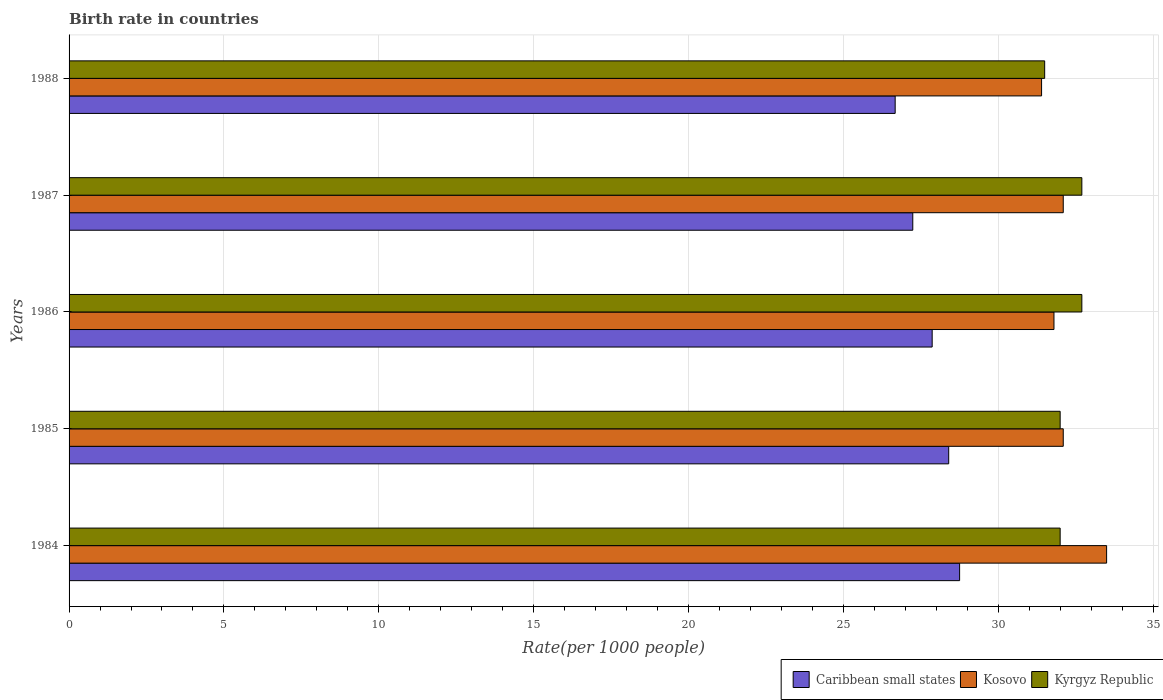How many different coloured bars are there?
Offer a terse response. 3. Are the number of bars on each tick of the Y-axis equal?
Offer a very short reply. Yes. In how many cases, is the number of bars for a given year not equal to the number of legend labels?
Your answer should be compact. 0. What is the birth rate in Kosovo in 1987?
Make the answer very short. 32.1. Across all years, what is the maximum birth rate in Kosovo?
Your answer should be very brief. 33.5. Across all years, what is the minimum birth rate in Caribbean small states?
Make the answer very short. 26.67. What is the total birth rate in Kosovo in the graph?
Give a very brief answer. 160.9. What is the difference between the birth rate in Kyrgyz Republic in 1984 and that in 1987?
Give a very brief answer. -0.7. What is the difference between the birth rate in Kyrgyz Republic in 1987 and the birth rate in Caribbean small states in 1985?
Keep it short and to the point. 4.3. What is the average birth rate in Kosovo per year?
Your answer should be very brief. 32.18. In the year 1986, what is the difference between the birth rate in Kyrgyz Republic and birth rate in Kosovo?
Your answer should be compact. 0.9. In how many years, is the birth rate in Caribbean small states greater than 26 ?
Your answer should be very brief. 5. What is the ratio of the birth rate in Caribbean small states in 1987 to that in 1988?
Your answer should be very brief. 1.02. Is the birth rate in Kosovo in 1985 less than that in 1988?
Your answer should be compact. No. Is the difference between the birth rate in Kyrgyz Republic in 1987 and 1988 greater than the difference between the birth rate in Kosovo in 1987 and 1988?
Offer a very short reply. Yes. What is the difference between the highest and the second highest birth rate in Caribbean small states?
Make the answer very short. 0.35. What is the difference between the highest and the lowest birth rate in Kosovo?
Provide a short and direct response. 2.1. In how many years, is the birth rate in Kyrgyz Republic greater than the average birth rate in Kyrgyz Republic taken over all years?
Your response must be concise. 2. Is the sum of the birth rate in Kyrgyz Republic in 1984 and 1988 greater than the maximum birth rate in Kosovo across all years?
Make the answer very short. Yes. What does the 2nd bar from the top in 1987 represents?
Your answer should be very brief. Kosovo. What does the 1st bar from the bottom in 1985 represents?
Your answer should be very brief. Caribbean small states. Is it the case that in every year, the sum of the birth rate in Caribbean small states and birth rate in Kosovo is greater than the birth rate in Kyrgyz Republic?
Provide a succinct answer. Yes. How many bars are there?
Your answer should be compact. 15. Are all the bars in the graph horizontal?
Offer a terse response. Yes. How many years are there in the graph?
Give a very brief answer. 5. Are the values on the major ticks of X-axis written in scientific E-notation?
Offer a very short reply. No. Where does the legend appear in the graph?
Make the answer very short. Bottom right. What is the title of the graph?
Make the answer very short. Birth rate in countries. What is the label or title of the X-axis?
Make the answer very short. Rate(per 1000 people). What is the label or title of the Y-axis?
Offer a terse response. Years. What is the Rate(per 1000 people) of Caribbean small states in 1984?
Provide a short and direct response. 28.75. What is the Rate(per 1000 people) in Kosovo in 1984?
Keep it short and to the point. 33.5. What is the Rate(per 1000 people) in Caribbean small states in 1985?
Provide a short and direct response. 28.4. What is the Rate(per 1000 people) of Kosovo in 1985?
Make the answer very short. 32.1. What is the Rate(per 1000 people) in Caribbean small states in 1986?
Offer a very short reply. 27.87. What is the Rate(per 1000 people) in Kosovo in 1986?
Offer a terse response. 31.8. What is the Rate(per 1000 people) of Kyrgyz Republic in 1986?
Offer a very short reply. 32.7. What is the Rate(per 1000 people) in Caribbean small states in 1987?
Your answer should be compact. 27.24. What is the Rate(per 1000 people) in Kosovo in 1987?
Offer a terse response. 32.1. What is the Rate(per 1000 people) in Kyrgyz Republic in 1987?
Give a very brief answer. 32.7. What is the Rate(per 1000 people) of Caribbean small states in 1988?
Your answer should be compact. 26.67. What is the Rate(per 1000 people) of Kosovo in 1988?
Your response must be concise. 31.4. What is the Rate(per 1000 people) of Kyrgyz Republic in 1988?
Your answer should be compact. 31.5. Across all years, what is the maximum Rate(per 1000 people) of Caribbean small states?
Give a very brief answer. 28.75. Across all years, what is the maximum Rate(per 1000 people) of Kosovo?
Your answer should be very brief. 33.5. Across all years, what is the maximum Rate(per 1000 people) of Kyrgyz Republic?
Your answer should be very brief. 32.7. Across all years, what is the minimum Rate(per 1000 people) of Caribbean small states?
Provide a short and direct response. 26.67. Across all years, what is the minimum Rate(per 1000 people) of Kosovo?
Offer a terse response. 31.4. Across all years, what is the minimum Rate(per 1000 people) of Kyrgyz Republic?
Offer a terse response. 31.5. What is the total Rate(per 1000 people) of Caribbean small states in the graph?
Provide a succinct answer. 138.94. What is the total Rate(per 1000 people) of Kosovo in the graph?
Offer a terse response. 160.9. What is the total Rate(per 1000 people) of Kyrgyz Republic in the graph?
Give a very brief answer. 160.9. What is the difference between the Rate(per 1000 people) of Caribbean small states in 1984 and that in 1985?
Offer a terse response. 0.35. What is the difference between the Rate(per 1000 people) of Caribbean small states in 1984 and that in 1986?
Your answer should be compact. 0.89. What is the difference between the Rate(per 1000 people) of Kyrgyz Republic in 1984 and that in 1986?
Keep it short and to the point. -0.7. What is the difference between the Rate(per 1000 people) of Caribbean small states in 1984 and that in 1987?
Your answer should be compact. 1.51. What is the difference between the Rate(per 1000 people) in Kosovo in 1984 and that in 1987?
Your answer should be compact. 1.4. What is the difference between the Rate(per 1000 people) of Kyrgyz Republic in 1984 and that in 1987?
Make the answer very short. -0.7. What is the difference between the Rate(per 1000 people) of Caribbean small states in 1984 and that in 1988?
Give a very brief answer. 2.08. What is the difference between the Rate(per 1000 people) of Kosovo in 1984 and that in 1988?
Keep it short and to the point. 2.1. What is the difference between the Rate(per 1000 people) of Kyrgyz Republic in 1984 and that in 1988?
Offer a terse response. 0.5. What is the difference between the Rate(per 1000 people) of Caribbean small states in 1985 and that in 1986?
Ensure brevity in your answer.  0.53. What is the difference between the Rate(per 1000 people) in Kyrgyz Republic in 1985 and that in 1986?
Provide a short and direct response. -0.7. What is the difference between the Rate(per 1000 people) of Caribbean small states in 1985 and that in 1987?
Make the answer very short. 1.16. What is the difference between the Rate(per 1000 people) in Caribbean small states in 1985 and that in 1988?
Your response must be concise. 1.73. What is the difference between the Rate(per 1000 people) of Kosovo in 1985 and that in 1988?
Ensure brevity in your answer.  0.7. What is the difference between the Rate(per 1000 people) in Caribbean small states in 1986 and that in 1987?
Give a very brief answer. 0.63. What is the difference between the Rate(per 1000 people) in Kyrgyz Republic in 1986 and that in 1987?
Offer a terse response. 0. What is the difference between the Rate(per 1000 people) of Caribbean small states in 1986 and that in 1988?
Give a very brief answer. 1.19. What is the difference between the Rate(per 1000 people) in Kosovo in 1986 and that in 1988?
Your answer should be very brief. 0.4. What is the difference between the Rate(per 1000 people) of Caribbean small states in 1987 and that in 1988?
Offer a terse response. 0.57. What is the difference between the Rate(per 1000 people) in Kosovo in 1987 and that in 1988?
Your answer should be compact. 0.7. What is the difference between the Rate(per 1000 people) of Kyrgyz Republic in 1987 and that in 1988?
Your answer should be compact. 1.2. What is the difference between the Rate(per 1000 people) in Caribbean small states in 1984 and the Rate(per 1000 people) in Kosovo in 1985?
Keep it short and to the point. -3.35. What is the difference between the Rate(per 1000 people) in Caribbean small states in 1984 and the Rate(per 1000 people) in Kyrgyz Republic in 1985?
Ensure brevity in your answer.  -3.25. What is the difference between the Rate(per 1000 people) in Caribbean small states in 1984 and the Rate(per 1000 people) in Kosovo in 1986?
Keep it short and to the point. -3.05. What is the difference between the Rate(per 1000 people) of Caribbean small states in 1984 and the Rate(per 1000 people) of Kyrgyz Republic in 1986?
Your answer should be compact. -3.95. What is the difference between the Rate(per 1000 people) in Caribbean small states in 1984 and the Rate(per 1000 people) in Kosovo in 1987?
Offer a terse response. -3.35. What is the difference between the Rate(per 1000 people) in Caribbean small states in 1984 and the Rate(per 1000 people) in Kyrgyz Republic in 1987?
Your response must be concise. -3.95. What is the difference between the Rate(per 1000 people) of Caribbean small states in 1984 and the Rate(per 1000 people) of Kosovo in 1988?
Your answer should be compact. -2.65. What is the difference between the Rate(per 1000 people) in Caribbean small states in 1984 and the Rate(per 1000 people) in Kyrgyz Republic in 1988?
Give a very brief answer. -2.75. What is the difference between the Rate(per 1000 people) in Caribbean small states in 1985 and the Rate(per 1000 people) in Kosovo in 1986?
Offer a terse response. -3.4. What is the difference between the Rate(per 1000 people) of Caribbean small states in 1985 and the Rate(per 1000 people) of Kyrgyz Republic in 1986?
Keep it short and to the point. -4.3. What is the difference between the Rate(per 1000 people) of Caribbean small states in 1985 and the Rate(per 1000 people) of Kosovo in 1987?
Your answer should be very brief. -3.7. What is the difference between the Rate(per 1000 people) of Caribbean small states in 1985 and the Rate(per 1000 people) of Kyrgyz Republic in 1987?
Your response must be concise. -4.3. What is the difference between the Rate(per 1000 people) in Kosovo in 1985 and the Rate(per 1000 people) in Kyrgyz Republic in 1987?
Give a very brief answer. -0.6. What is the difference between the Rate(per 1000 people) in Caribbean small states in 1985 and the Rate(per 1000 people) in Kosovo in 1988?
Provide a succinct answer. -3. What is the difference between the Rate(per 1000 people) in Caribbean small states in 1985 and the Rate(per 1000 people) in Kyrgyz Republic in 1988?
Give a very brief answer. -3.1. What is the difference between the Rate(per 1000 people) in Caribbean small states in 1986 and the Rate(per 1000 people) in Kosovo in 1987?
Your response must be concise. -4.23. What is the difference between the Rate(per 1000 people) of Caribbean small states in 1986 and the Rate(per 1000 people) of Kyrgyz Republic in 1987?
Offer a terse response. -4.83. What is the difference between the Rate(per 1000 people) in Kosovo in 1986 and the Rate(per 1000 people) in Kyrgyz Republic in 1987?
Your answer should be very brief. -0.9. What is the difference between the Rate(per 1000 people) in Caribbean small states in 1986 and the Rate(per 1000 people) in Kosovo in 1988?
Provide a short and direct response. -3.53. What is the difference between the Rate(per 1000 people) in Caribbean small states in 1986 and the Rate(per 1000 people) in Kyrgyz Republic in 1988?
Offer a very short reply. -3.63. What is the difference between the Rate(per 1000 people) in Kosovo in 1986 and the Rate(per 1000 people) in Kyrgyz Republic in 1988?
Offer a very short reply. 0.3. What is the difference between the Rate(per 1000 people) of Caribbean small states in 1987 and the Rate(per 1000 people) of Kosovo in 1988?
Make the answer very short. -4.16. What is the difference between the Rate(per 1000 people) of Caribbean small states in 1987 and the Rate(per 1000 people) of Kyrgyz Republic in 1988?
Make the answer very short. -4.26. What is the average Rate(per 1000 people) of Caribbean small states per year?
Keep it short and to the point. 27.79. What is the average Rate(per 1000 people) of Kosovo per year?
Your answer should be very brief. 32.18. What is the average Rate(per 1000 people) of Kyrgyz Republic per year?
Offer a terse response. 32.18. In the year 1984, what is the difference between the Rate(per 1000 people) of Caribbean small states and Rate(per 1000 people) of Kosovo?
Offer a very short reply. -4.75. In the year 1984, what is the difference between the Rate(per 1000 people) in Caribbean small states and Rate(per 1000 people) in Kyrgyz Republic?
Keep it short and to the point. -3.25. In the year 1985, what is the difference between the Rate(per 1000 people) of Caribbean small states and Rate(per 1000 people) of Kosovo?
Offer a very short reply. -3.7. In the year 1985, what is the difference between the Rate(per 1000 people) of Caribbean small states and Rate(per 1000 people) of Kyrgyz Republic?
Your answer should be compact. -3.6. In the year 1985, what is the difference between the Rate(per 1000 people) in Kosovo and Rate(per 1000 people) in Kyrgyz Republic?
Offer a very short reply. 0.1. In the year 1986, what is the difference between the Rate(per 1000 people) in Caribbean small states and Rate(per 1000 people) in Kosovo?
Provide a succinct answer. -3.93. In the year 1986, what is the difference between the Rate(per 1000 people) of Caribbean small states and Rate(per 1000 people) of Kyrgyz Republic?
Your response must be concise. -4.83. In the year 1986, what is the difference between the Rate(per 1000 people) in Kosovo and Rate(per 1000 people) in Kyrgyz Republic?
Give a very brief answer. -0.9. In the year 1987, what is the difference between the Rate(per 1000 people) in Caribbean small states and Rate(per 1000 people) in Kosovo?
Your response must be concise. -4.86. In the year 1987, what is the difference between the Rate(per 1000 people) of Caribbean small states and Rate(per 1000 people) of Kyrgyz Republic?
Offer a terse response. -5.46. In the year 1988, what is the difference between the Rate(per 1000 people) in Caribbean small states and Rate(per 1000 people) in Kosovo?
Your answer should be very brief. -4.73. In the year 1988, what is the difference between the Rate(per 1000 people) of Caribbean small states and Rate(per 1000 people) of Kyrgyz Republic?
Your response must be concise. -4.83. What is the ratio of the Rate(per 1000 people) of Caribbean small states in 1984 to that in 1985?
Offer a terse response. 1.01. What is the ratio of the Rate(per 1000 people) in Kosovo in 1984 to that in 1985?
Make the answer very short. 1.04. What is the ratio of the Rate(per 1000 people) of Kyrgyz Republic in 1984 to that in 1985?
Offer a very short reply. 1. What is the ratio of the Rate(per 1000 people) of Caribbean small states in 1984 to that in 1986?
Your answer should be compact. 1.03. What is the ratio of the Rate(per 1000 people) in Kosovo in 1984 to that in 1986?
Make the answer very short. 1.05. What is the ratio of the Rate(per 1000 people) of Kyrgyz Republic in 1984 to that in 1986?
Ensure brevity in your answer.  0.98. What is the ratio of the Rate(per 1000 people) of Caribbean small states in 1984 to that in 1987?
Keep it short and to the point. 1.06. What is the ratio of the Rate(per 1000 people) in Kosovo in 1984 to that in 1987?
Offer a very short reply. 1.04. What is the ratio of the Rate(per 1000 people) of Kyrgyz Republic in 1984 to that in 1987?
Your answer should be very brief. 0.98. What is the ratio of the Rate(per 1000 people) in Caribbean small states in 1984 to that in 1988?
Your response must be concise. 1.08. What is the ratio of the Rate(per 1000 people) of Kosovo in 1984 to that in 1988?
Keep it short and to the point. 1.07. What is the ratio of the Rate(per 1000 people) in Kyrgyz Republic in 1984 to that in 1988?
Your response must be concise. 1.02. What is the ratio of the Rate(per 1000 people) in Caribbean small states in 1985 to that in 1986?
Provide a short and direct response. 1.02. What is the ratio of the Rate(per 1000 people) of Kosovo in 1985 to that in 1986?
Offer a very short reply. 1.01. What is the ratio of the Rate(per 1000 people) of Kyrgyz Republic in 1985 to that in 1986?
Your answer should be compact. 0.98. What is the ratio of the Rate(per 1000 people) in Caribbean small states in 1985 to that in 1987?
Offer a terse response. 1.04. What is the ratio of the Rate(per 1000 people) of Kosovo in 1985 to that in 1987?
Provide a short and direct response. 1. What is the ratio of the Rate(per 1000 people) in Kyrgyz Republic in 1985 to that in 1987?
Your answer should be very brief. 0.98. What is the ratio of the Rate(per 1000 people) in Caribbean small states in 1985 to that in 1988?
Offer a very short reply. 1.06. What is the ratio of the Rate(per 1000 people) of Kosovo in 1985 to that in 1988?
Offer a terse response. 1.02. What is the ratio of the Rate(per 1000 people) in Kyrgyz Republic in 1985 to that in 1988?
Make the answer very short. 1.02. What is the ratio of the Rate(per 1000 people) of Caribbean small states in 1986 to that in 1988?
Give a very brief answer. 1.04. What is the ratio of the Rate(per 1000 people) in Kosovo in 1986 to that in 1988?
Keep it short and to the point. 1.01. What is the ratio of the Rate(per 1000 people) in Kyrgyz Republic in 1986 to that in 1988?
Your answer should be compact. 1.04. What is the ratio of the Rate(per 1000 people) in Caribbean small states in 1987 to that in 1988?
Offer a terse response. 1.02. What is the ratio of the Rate(per 1000 people) of Kosovo in 1987 to that in 1988?
Offer a terse response. 1.02. What is the ratio of the Rate(per 1000 people) of Kyrgyz Republic in 1987 to that in 1988?
Keep it short and to the point. 1.04. What is the difference between the highest and the second highest Rate(per 1000 people) of Caribbean small states?
Your response must be concise. 0.35. What is the difference between the highest and the lowest Rate(per 1000 people) in Caribbean small states?
Your answer should be very brief. 2.08. What is the difference between the highest and the lowest Rate(per 1000 people) of Kosovo?
Offer a very short reply. 2.1. What is the difference between the highest and the lowest Rate(per 1000 people) of Kyrgyz Republic?
Ensure brevity in your answer.  1.2. 